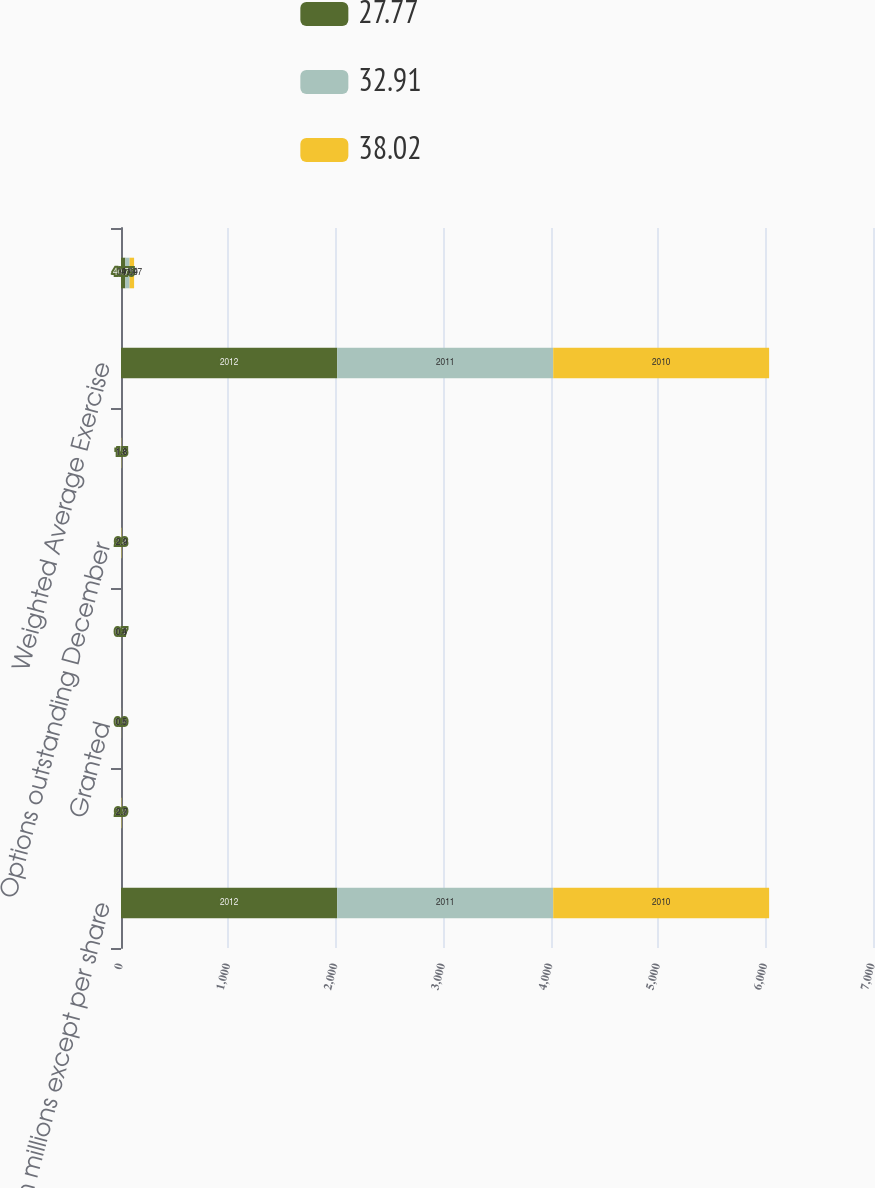Convert chart to OTSL. <chart><loc_0><loc_0><loc_500><loc_500><stacked_bar_chart><ecel><fcel>(in millions except per share<fcel>Options outstanding January 1<fcel>Granted<fcel>Exercised<fcel>Options outstanding December<fcel>Options exercisable December<fcel>Weighted Average Exercise<fcel>Forfeited<nl><fcel>27.77<fcel>2012<fcel>2.9<fcel>0.6<fcel>0.7<fcel>2.8<fcel>1.5<fcel>2012<fcel>40.75<nl><fcel>32.91<fcel>2011<fcel>2.9<fcel>0.5<fcel>0.4<fcel>2.9<fcel>1.8<fcel>2011<fcel>39.69<nl><fcel>38.02<fcel>2010<fcel>2.7<fcel>0.6<fcel>0.3<fcel>2.9<fcel>1.8<fcel>2010<fcel>41.47<nl></chart> 